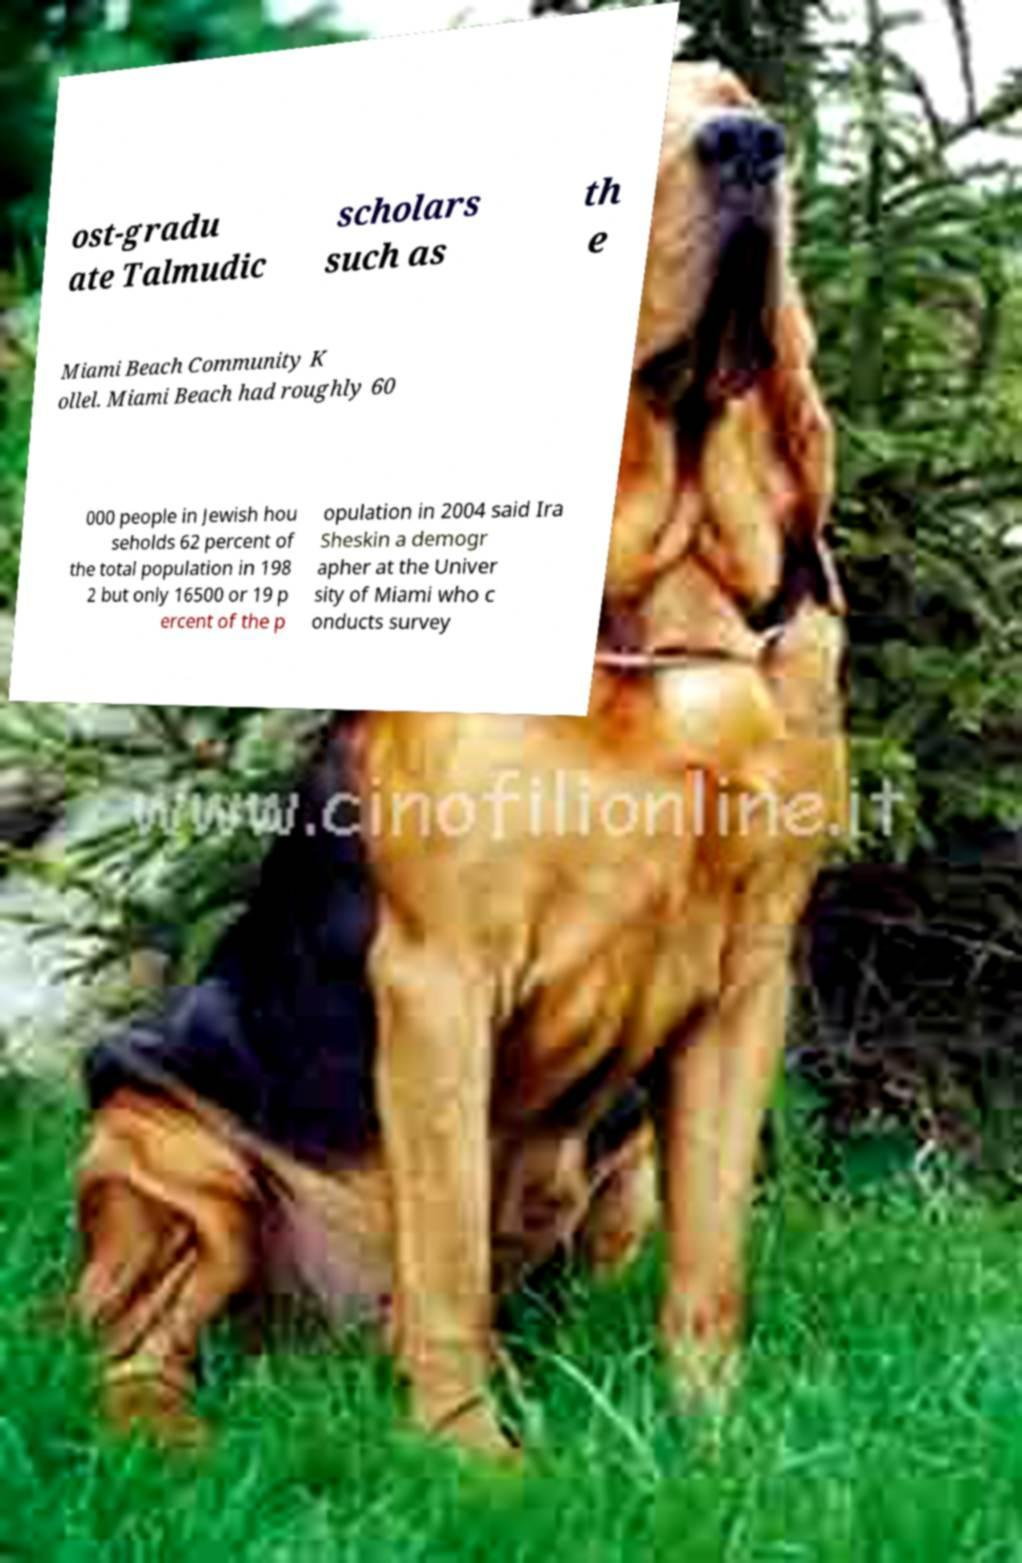Could you assist in decoding the text presented in this image and type it out clearly? ost-gradu ate Talmudic scholars such as th e Miami Beach Community K ollel. Miami Beach had roughly 60 000 people in Jewish hou seholds 62 percent of the total population in 198 2 but only 16500 or 19 p ercent of the p opulation in 2004 said Ira Sheskin a demogr apher at the Univer sity of Miami who c onducts survey 